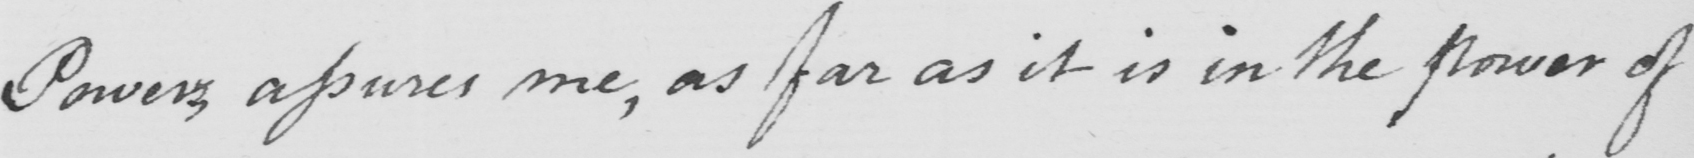What does this handwritten line say? Power assures me, as far as it is in the power of 